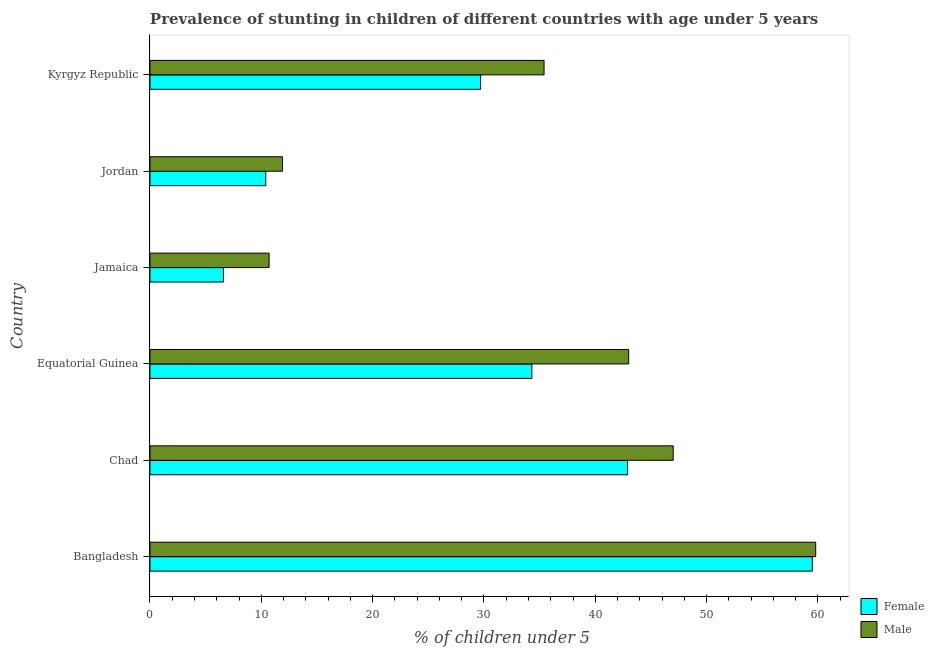How many different coloured bars are there?
Make the answer very short. 2. Are the number of bars on each tick of the Y-axis equal?
Make the answer very short. Yes. How many bars are there on the 3rd tick from the top?
Your answer should be very brief. 2. What is the label of the 1st group of bars from the top?
Provide a succinct answer. Kyrgyz Republic. In how many cases, is the number of bars for a given country not equal to the number of legend labels?
Offer a very short reply. 0. What is the percentage of stunted male children in Jamaica?
Your answer should be very brief. 10.7. Across all countries, what is the maximum percentage of stunted female children?
Your answer should be very brief. 59.5. Across all countries, what is the minimum percentage of stunted male children?
Keep it short and to the point. 10.7. In which country was the percentage of stunted female children minimum?
Keep it short and to the point. Jamaica. What is the total percentage of stunted male children in the graph?
Your answer should be compact. 207.8. What is the difference between the percentage of stunted male children in Bangladesh and that in Jamaica?
Offer a terse response. 49.1. What is the difference between the percentage of stunted male children in Equatorial Guinea and the percentage of stunted female children in Kyrgyz Republic?
Offer a terse response. 13.3. What is the average percentage of stunted male children per country?
Provide a short and direct response. 34.63. What is the ratio of the percentage of stunted male children in Equatorial Guinea to that in Jamaica?
Ensure brevity in your answer.  4.02. Is the difference between the percentage of stunted female children in Bangladesh and Chad greater than the difference between the percentage of stunted male children in Bangladesh and Chad?
Offer a terse response. Yes. What is the difference between the highest and the lowest percentage of stunted female children?
Make the answer very short. 52.9. Is the sum of the percentage of stunted female children in Bangladesh and Jordan greater than the maximum percentage of stunted male children across all countries?
Give a very brief answer. Yes. What does the 2nd bar from the bottom in Kyrgyz Republic represents?
Make the answer very short. Male. Are all the bars in the graph horizontal?
Give a very brief answer. Yes. What is the difference between two consecutive major ticks on the X-axis?
Give a very brief answer. 10. Are the values on the major ticks of X-axis written in scientific E-notation?
Ensure brevity in your answer.  No. Does the graph contain any zero values?
Your answer should be very brief. No. Does the graph contain grids?
Provide a short and direct response. No. Where does the legend appear in the graph?
Offer a terse response. Bottom right. How are the legend labels stacked?
Make the answer very short. Vertical. What is the title of the graph?
Your answer should be very brief. Prevalence of stunting in children of different countries with age under 5 years. What is the label or title of the X-axis?
Make the answer very short.  % of children under 5. What is the  % of children under 5 of Female in Bangladesh?
Your answer should be very brief. 59.5. What is the  % of children under 5 in Male in Bangladesh?
Your answer should be compact. 59.8. What is the  % of children under 5 in Female in Chad?
Your answer should be very brief. 42.9. What is the  % of children under 5 in Female in Equatorial Guinea?
Provide a succinct answer. 34.3. What is the  % of children under 5 of Male in Equatorial Guinea?
Provide a succinct answer. 43. What is the  % of children under 5 in Female in Jamaica?
Your response must be concise. 6.6. What is the  % of children under 5 of Male in Jamaica?
Ensure brevity in your answer.  10.7. What is the  % of children under 5 in Female in Jordan?
Make the answer very short. 10.4. What is the  % of children under 5 of Male in Jordan?
Keep it short and to the point. 11.9. What is the  % of children under 5 of Female in Kyrgyz Republic?
Give a very brief answer. 29.7. What is the  % of children under 5 in Male in Kyrgyz Republic?
Your answer should be compact. 35.4. Across all countries, what is the maximum  % of children under 5 of Female?
Provide a succinct answer. 59.5. Across all countries, what is the maximum  % of children under 5 of Male?
Give a very brief answer. 59.8. Across all countries, what is the minimum  % of children under 5 in Female?
Offer a very short reply. 6.6. Across all countries, what is the minimum  % of children under 5 in Male?
Provide a succinct answer. 10.7. What is the total  % of children under 5 of Female in the graph?
Make the answer very short. 183.4. What is the total  % of children under 5 of Male in the graph?
Ensure brevity in your answer.  207.8. What is the difference between the  % of children under 5 of Female in Bangladesh and that in Chad?
Your response must be concise. 16.6. What is the difference between the  % of children under 5 in Male in Bangladesh and that in Chad?
Offer a terse response. 12.8. What is the difference between the  % of children under 5 of Female in Bangladesh and that in Equatorial Guinea?
Your answer should be very brief. 25.2. What is the difference between the  % of children under 5 in Male in Bangladesh and that in Equatorial Guinea?
Ensure brevity in your answer.  16.8. What is the difference between the  % of children under 5 in Female in Bangladesh and that in Jamaica?
Make the answer very short. 52.9. What is the difference between the  % of children under 5 of Male in Bangladesh and that in Jamaica?
Give a very brief answer. 49.1. What is the difference between the  % of children under 5 of Female in Bangladesh and that in Jordan?
Your response must be concise. 49.1. What is the difference between the  % of children under 5 in Male in Bangladesh and that in Jordan?
Give a very brief answer. 47.9. What is the difference between the  % of children under 5 of Female in Bangladesh and that in Kyrgyz Republic?
Ensure brevity in your answer.  29.8. What is the difference between the  % of children under 5 of Male in Bangladesh and that in Kyrgyz Republic?
Your response must be concise. 24.4. What is the difference between the  % of children under 5 in Male in Chad and that in Equatorial Guinea?
Make the answer very short. 4. What is the difference between the  % of children under 5 in Female in Chad and that in Jamaica?
Keep it short and to the point. 36.3. What is the difference between the  % of children under 5 in Male in Chad and that in Jamaica?
Provide a short and direct response. 36.3. What is the difference between the  % of children under 5 in Female in Chad and that in Jordan?
Give a very brief answer. 32.5. What is the difference between the  % of children under 5 in Male in Chad and that in Jordan?
Make the answer very short. 35.1. What is the difference between the  % of children under 5 of Male in Chad and that in Kyrgyz Republic?
Your response must be concise. 11.6. What is the difference between the  % of children under 5 of Female in Equatorial Guinea and that in Jamaica?
Keep it short and to the point. 27.7. What is the difference between the  % of children under 5 of Male in Equatorial Guinea and that in Jamaica?
Your answer should be compact. 32.3. What is the difference between the  % of children under 5 in Female in Equatorial Guinea and that in Jordan?
Keep it short and to the point. 23.9. What is the difference between the  % of children under 5 of Male in Equatorial Guinea and that in Jordan?
Make the answer very short. 31.1. What is the difference between the  % of children under 5 in Male in Equatorial Guinea and that in Kyrgyz Republic?
Offer a terse response. 7.6. What is the difference between the  % of children under 5 of Female in Jamaica and that in Kyrgyz Republic?
Your answer should be compact. -23.1. What is the difference between the  % of children under 5 of Male in Jamaica and that in Kyrgyz Republic?
Keep it short and to the point. -24.7. What is the difference between the  % of children under 5 of Female in Jordan and that in Kyrgyz Republic?
Provide a succinct answer. -19.3. What is the difference between the  % of children under 5 of Male in Jordan and that in Kyrgyz Republic?
Provide a short and direct response. -23.5. What is the difference between the  % of children under 5 in Female in Bangladesh and the  % of children under 5 in Male in Chad?
Provide a short and direct response. 12.5. What is the difference between the  % of children under 5 in Female in Bangladesh and the  % of children under 5 in Male in Equatorial Guinea?
Keep it short and to the point. 16.5. What is the difference between the  % of children under 5 of Female in Bangladesh and the  % of children under 5 of Male in Jamaica?
Offer a terse response. 48.8. What is the difference between the  % of children under 5 in Female in Bangladesh and the  % of children under 5 in Male in Jordan?
Make the answer very short. 47.6. What is the difference between the  % of children under 5 in Female in Bangladesh and the  % of children under 5 in Male in Kyrgyz Republic?
Your answer should be very brief. 24.1. What is the difference between the  % of children under 5 in Female in Chad and the  % of children under 5 in Male in Equatorial Guinea?
Offer a terse response. -0.1. What is the difference between the  % of children under 5 of Female in Chad and the  % of children under 5 of Male in Jamaica?
Your response must be concise. 32.2. What is the difference between the  % of children under 5 of Female in Chad and the  % of children under 5 of Male in Jordan?
Provide a short and direct response. 31. What is the difference between the  % of children under 5 of Female in Chad and the  % of children under 5 of Male in Kyrgyz Republic?
Give a very brief answer. 7.5. What is the difference between the  % of children under 5 of Female in Equatorial Guinea and the  % of children under 5 of Male in Jamaica?
Ensure brevity in your answer.  23.6. What is the difference between the  % of children under 5 of Female in Equatorial Guinea and the  % of children under 5 of Male in Jordan?
Ensure brevity in your answer.  22.4. What is the difference between the  % of children under 5 of Female in Jamaica and the  % of children under 5 of Male in Jordan?
Ensure brevity in your answer.  -5.3. What is the difference between the  % of children under 5 of Female in Jamaica and the  % of children under 5 of Male in Kyrgyz Republic?
Offer a terse response. -28.8. What is the difference between the  % of children under 5 in Female in Jordan and the  % of children under 5 in Male in Kyrgyz Republic?
Keep it short and to the point. -25. What is the average  % of children under 5 in Female per country?
Make the answer very short. 30.57. What is the average  % of children under 5 of Male per country?
Provide a short and direct response. 34.63. What is the difference between the  % of children under 5 in Female and  % of children under 5 in Male in Equatorial Guinea?
Keep it short and to the point. -8.7. What is the difference between the  % of children under 5 in Female and  % of children under 5 in Male in Jordan?
Offer a terse response. -1.5. What is the difference between the  % of children under 5 of Female and  % of children under 5 of Male in Kyrgyz Republic?
Provide a short and direct response. -5.7. What is the ratio of the  % of children under 5 in Female in Bangladesh to that in Chad?
Your answer should be compact. 1.39. What is the ratio of the  % of children under 5 of Male in Bangladesh to that in Chad?
Your answer should be compact. 1.27. What is the ratio of the  % of children under 5 in Female in Bangladesh to that in Equatorial Guinea?
Your response must be concise. 1.73. What is the ratio of the  % of children under 5 in Male in Bangladesh to that in Equatorial Guinea?
Keep it short and to the point. 1.39. What is the ratio of the  % of children under 5 of Female in Bangladesh to that in Jamaica?
Offer a very short reply. 9.02. What is the ratio of the  % of children under 5 of Male in Bangladesh to that in Jamaica?
Provide a short and direct response. 5.59. What is the ratio of the  % of children under 5 of Female in Bangladesh to that in Jordan?
Offer a terse response. 5.72. What is the ratio of the  % of children under 5 of Male in Bangladesh to that in Jordan?
Offer a terse response. 5.03. What is the ratio of the  % of children under 5 of Female in Bangladesh to that in Kyrgyz Republic?
Make the answer very short. 2. What is the ratio of the  % of children under 5 in Male in Bangladesh to that in Kyrgyz Republic?
Provide a short and direct response. 1.69. What is the ratio of the  % of children under 5 in Female in Chad to that in Equatorial Guinea?
Your answer should be compact. 1.25. What is the ratio of the  % of children under 5 in Male in Chad to that in Equatorial Guinea?
Offer a very short reply. 1.09. What is the ratio of the  % of children under 5 of Male in Chad to that in Jamaica?
Provide a succinct answer. 4.39. What is the ratio of the  % of children under 5 in Female in Chad to that in Jordan?
Make the answer very short. 4.12. What is the ratio of the  % of children under 5 in Male in Chad to that in Jordan?
Offer a very short reply. 3.95. What is the ratio of the  % of children under 5 in Female in Chad to that in Kyrgyz Republic?
Provide a short and direct response. 1.44. What is the ratio of the  % of children under 5 of Male in Chad to that in Kyrgyz Republic?
Give a very brief answer. 1.33. What is the ratio of the  % of children under 5 in Female in Equatorial Guinea to that in Jamaica?
Your answer should be very brief. 5.2. What is the ratio of the  % of children under 5 in Male in Equatorial Guinea to that in Jamaica?
Give a very brief answer. 4.02. What is the ratio of the  % of children under 5 in Female in Equatorial Guinea to that in Jordan?
Offer a very short reply. 3.3. What is the ratio of the  % of children under 5 of Male in Equatorial Guinea to that in Jordan?
Provide a short and direct response. 3.61. What is the ratio of the  % of children under 5 of Female in Equatorial Guinea to that in Kyrgyz Republic?
Offer a terse response. 1.15. What is the ratio of the  % of children under 5 in Male in Equatorial Guinea to that in Kyrgyz Republic?
Make the answer very short. 1.21. What is the ratio of the  % of children under 5 of Female in Jamaica to that in Jordan?
Make the answer very short. 0.63. What is the ratio of the  % of children under 5 in Male in Jamaica to that in Jordan?
Ensure brevity in your answer.  0.9. What is the ratio of the  % of children under 5 of Female in Jamaica to that in Kyrgyz Republic?
Ensure brevity in your answer.  0.22. What is the ratio of the  % of children under 5 in Male in Jamaica to that in Kyrgyz Republic?
Ensure brevity in your answer.  0.3. What is the ratio of the  % of children under 5 of Female in Jordan to that in Kyrgyz Republic?
Offer a very short reply. 0.35. What is the ratio of the  % of children under 5 of Male in Jordan to that in Kyrgyz Republic?
Make the answer very short. 0.34. What is the difference between the highest and the second highest  % of children under 5 in Female?
Your response must be concise. 16.6. What is the difference between the highest and the second highest  % of children under 5 of Male?
Give a very brief answer. 12.8. What is the difference between the highest and the lowest  % of children under 5 of Female?
Your answer should be compact. 52.9. What is the difference between the highest and the lowest  % of children under 5 in Male?
Keep it short and to the point. 49.1. 